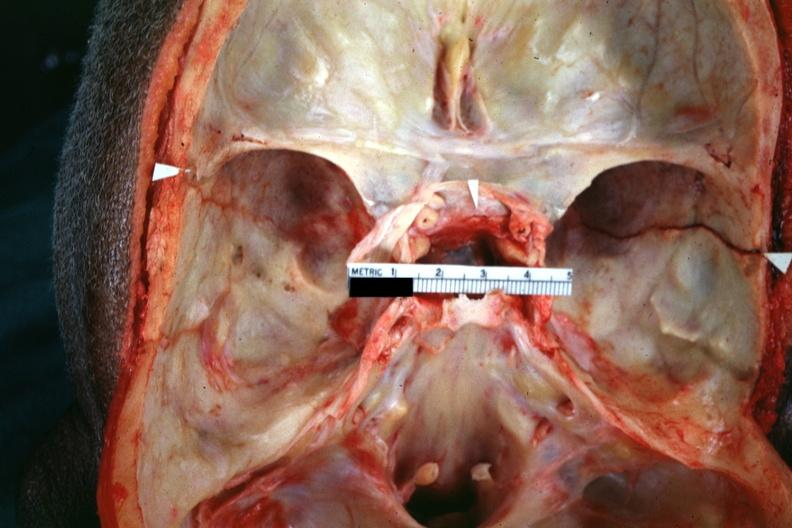what shown fracture line?
Answer the question using a single word or phrase. Close-up view 